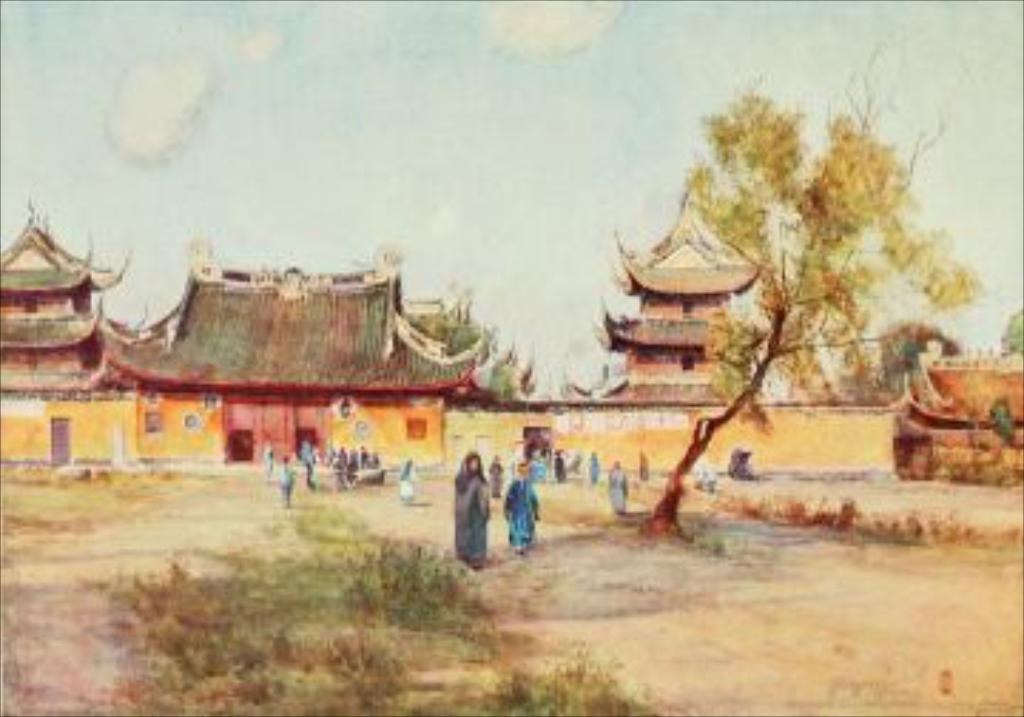What are the people in the image doing? The people in the image are walking. On what surface are the people walking? The people are walking on the ground. What natural element can be seen in the image? There is a tree in the image. What can be seen in the distance in the image? There are houses in the background of the image, and the sky is visible as well. What type of cakes are being served at the street party in the image? There is no street party or cakes present in the image; it features people walking on the ground with a tree and houses in the background. Can you tell me how many glasses of eggnog are being consumed by the people in the image? There is no eggnog or consumption of any beverage visible in the image. 